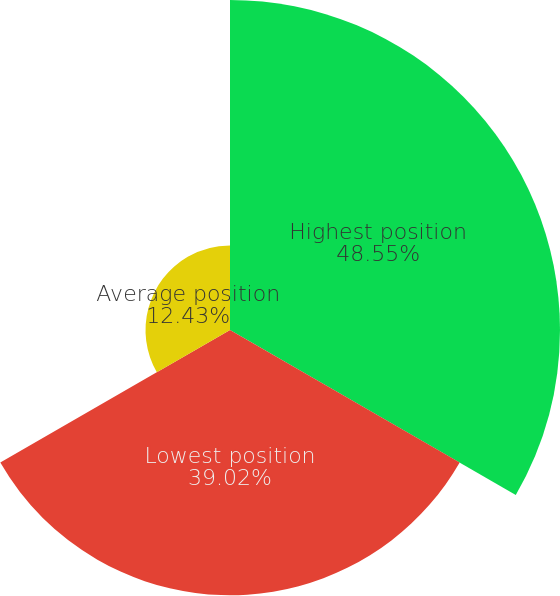<chart> <loc_0><loc_0><loc_500><loc_500><pie_chart><fcel>Highest position<fcel>Lowest position<fcel>Average position<nl><fcel>48.55%<fcel>39.02%<fcel>12.43%<nl></chart> 